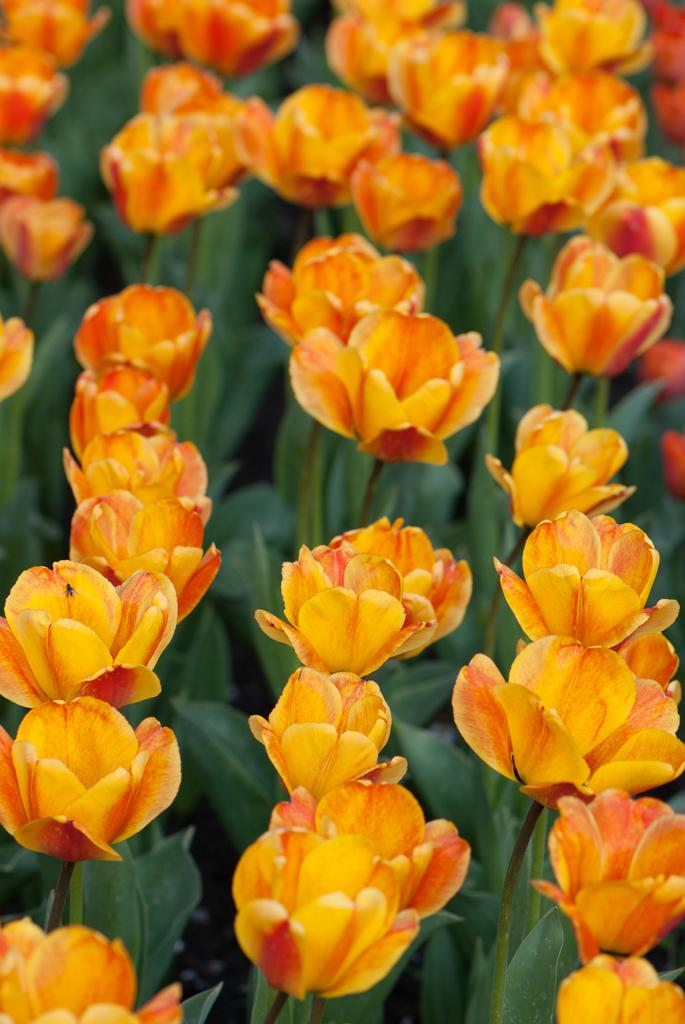What color are the flowers in the image? The flowers in the image are orange. How are the flowers arranged in the image? The flowers are arranged in lines. What else can be seen at the bottom of the image? There are leaves at the bottom of the image. What type of party is being held in the image? There is no party present in the image; it features orange flowers arranged in lines with leaves at the bottom. Can you see a coil or a scarecrow in the image? No, there is no coil or scarecrow present in the image. 